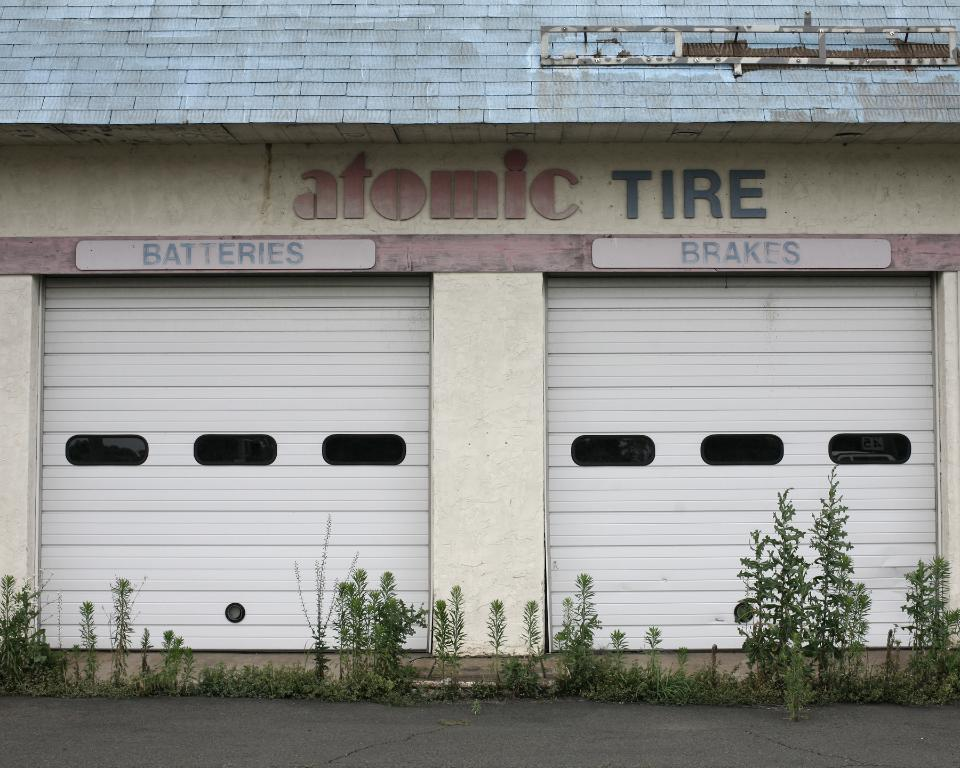What is the main feature of the image? There is a road in the image. What else can be seen in the image besides the road? There is a building in the image. Can you describe what is written on top of the building? Something is written on top of the building, but the specific text is not mentioned in the facts. What type of vegetation is in front of the building? There are plants in front of the building. What type of hospital can be seen in the image? There is no hospital present in the image. Is there a protest happening in front of the building in the image? There is no indication of a protest in the image. 